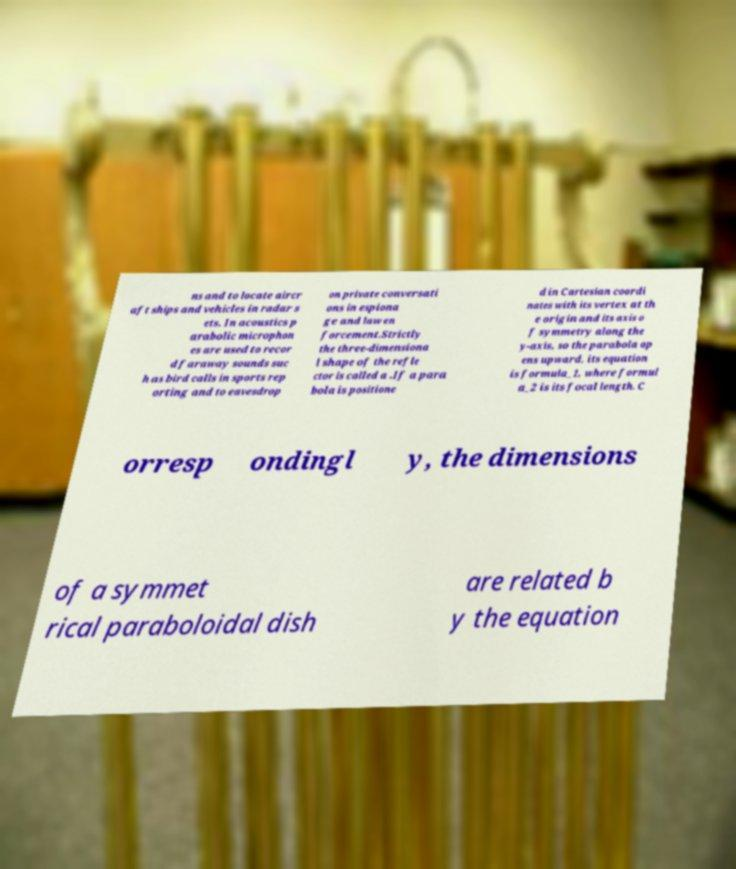Can you accurately transcribe the text from the provided image for me? ns and to locate aircr aft ships and vehicles in radar s ets. In acoustics p arabolic microphon es are used to recor d faraway sounds suc h as bird calls in sports rep orting and to eavesdrop on private conversati ons in espiona ge and law en forcement.Strictly the three-dimensiona l shape of the refle ctor is called a .If a para bola is positione d in Cartesian coordi nates with its vertex at th e origin and its axis o f symmetry along the y-axis, so the parabola op ens upward, its equation is formula_1, where formul a_2 is its focal length. C orresp ondingl y, the dimensions of a symmet rical paraboloidal dish are related b y the equation 